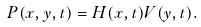<formula> <loc_0><loc_0><loc_500><loc_500>P ( x , y , t ) = H ( x , t ) V ( y , t ) .</formula> 